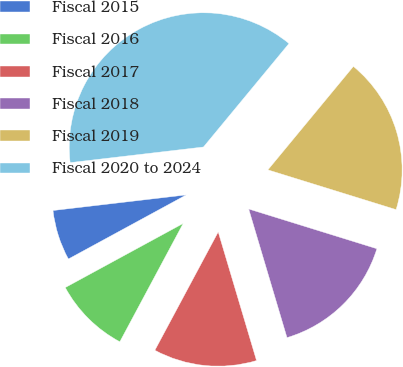Convert chart to OTSL. <chart><loc_0><loc_0><loc_500><loc_500><pie_chart><fcel>Fiscal 2015<fcel>Fiscal 2016<fcel>Fiscal 2017<fcel>Fiscal 2018<fcel>Fiscal 2019<fcel>Fiscal 2020 to 2024<nl><fcel>6.07%<fcel>9.25%<fcel>12.43%<fcel>15.61%<fcel>18.79%<fcel>37.85%<nl></chart> 